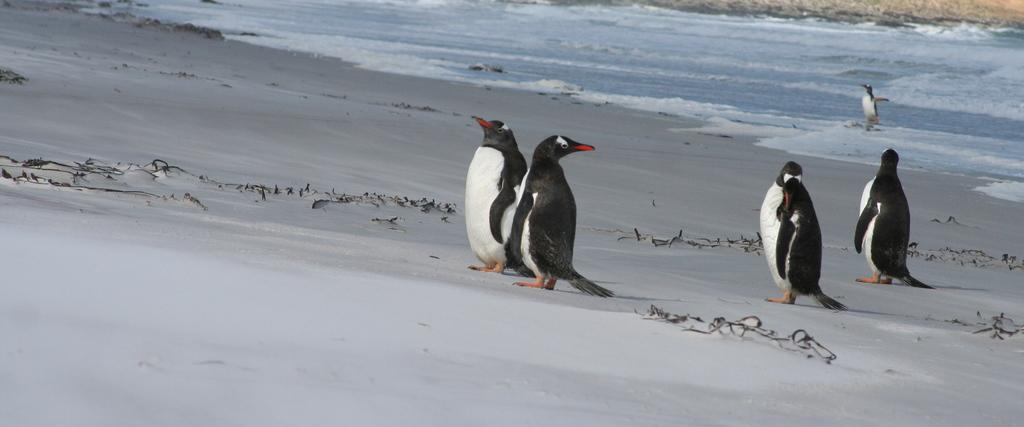What type of animals are present in the image? There are penguins in the image. What is the primary element in which the penguins are situated? There is water visible in the image, and the penguins are in the water. What type of island can be seen in the background of the image? There is no island present in the image; it features penguins in water. What joke is the penguin telling in the image? There is no joke being told in the image, as it simply shows penguins in water. 